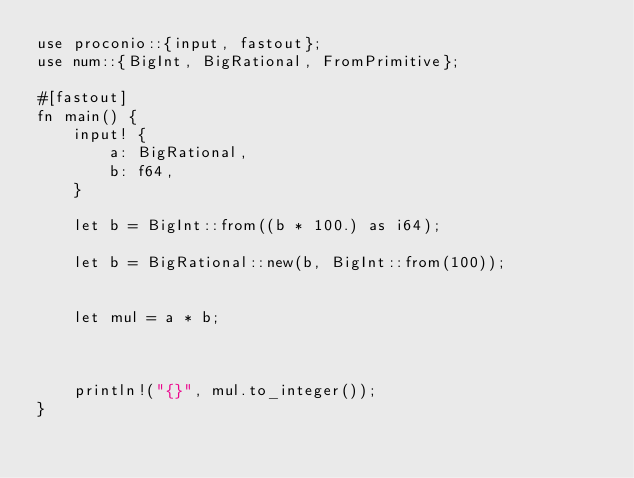<code> <loc_0><loc_0><loc_500><loc_500><_Rust_>use proconio::{input, fastout};
use num::{BigInt, BigRational, FromPrimitive};

#[fastout]
fn main() {
    input! {
        a: BigRational,
        b: f64,
    }

    let b = BigInt::from((b * 100.) as i64);

    let b = BigRational::new(b, BigInt::from(100));


    let mul = a * b;



    println!("{}", mul.to_integer());
}</code> 